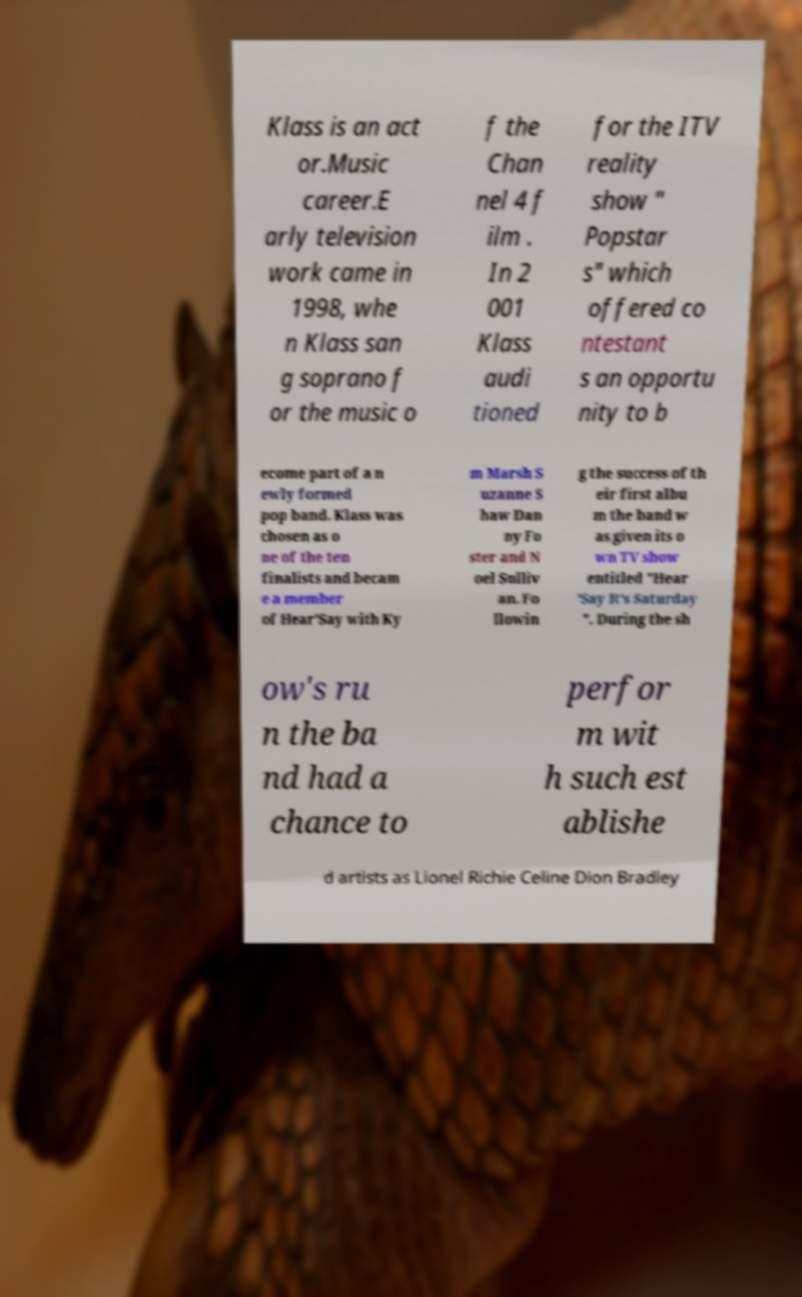What messages or text are displayed in this image? I need them in a readable, typed format. Klass is an act or.Music career.E arly television work came in 1998, whe n Klass san g soprano f or the music o f the Chan nel 4 f ilm . In 2 001 Klass audi tioned for the ITV reality show " Popstar s" which offered co ntestant s an opportu nity to b ecome part of a n ewly formed pop band. Klass was chosen as o ne of the ten finalists and becam e a member of Hear'Say with Ky m Marsh S uzanne S haw Dan ny Fo ster and N oel Sulliv an. Fo llowin g the success of th eir first albu m the band w as given its o wn TV show entitled "Hear 'Say It's Saturday ". During the sh ow's ru n the ba nd had a chance to perfor m wit h such est ablishe d artists as Lionel Richie Celine Dion Bradley 